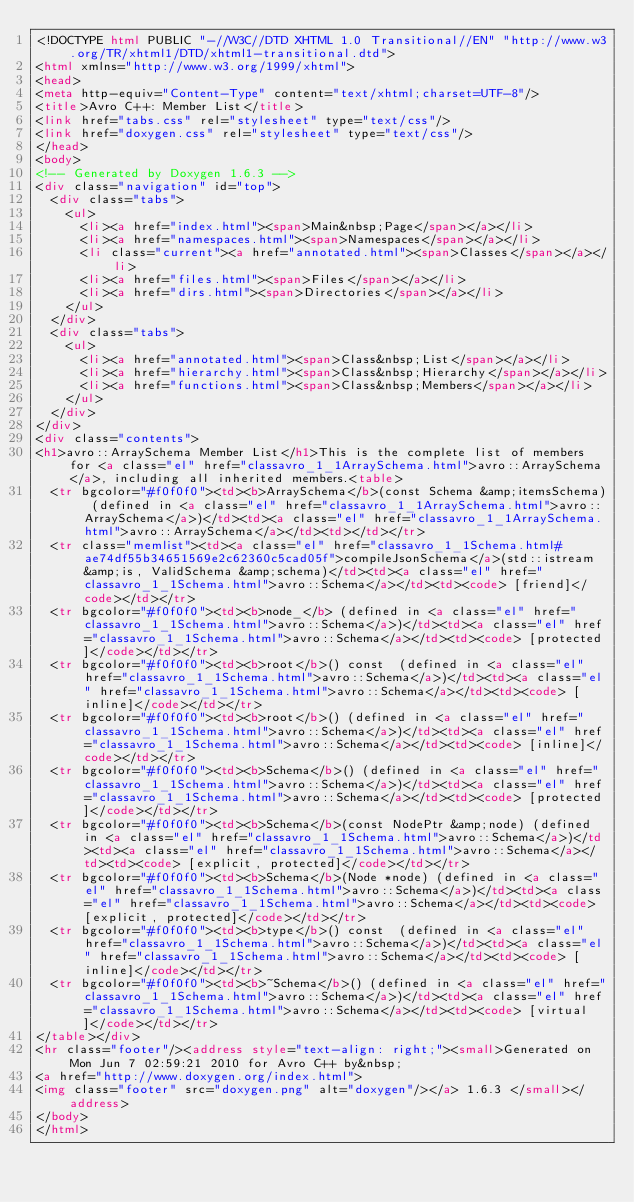Convert code to text. <code><loc_0><loc_0><loc_500><loc_500><_HTML_><!DOCTYPE html PUBLIC "-//W3C//DTD XHTML 1.0 Transitional//EN" "http://www.w3.org/TR/xhtml1/DTD/xhtml1-transitional.dtd">
<html xmlns="http://www.w3.org/1999/xhtml">
<head>
<meta http-equiv="Content-Type" content="text/xhtml;charset=UTF-8"/>
<title>Avro C++: Member List</title>
<link href="tabs.css" rel="stylesheet" type="text/css"/>
<link href="doxygen.css" rel="stylesheet" type="text/css"/>
</head>
<body>
<!-- Generated by Doxygen 1.6.3 -->
<div class="navigation" id="top">
  <div class="tabs">
    <ul>
      <li><a href="index.html"><span>Main&nbsp;Page</span></a></li>
      <li><a href="namespaces.html"><span>Namespaces</span></a></li>
      <li class="current"><a href="annotated.html"><span>Classes</span></a></li>
      <li><a href="files.html"><span>Files</span></a></li>
      <li><a href="dirs.html"><span>Directories</span></a></li>
    </ul>
  </div>
  <div class="tabs">
    <ul>
      <li><a href="annotated.html"><span>Class&nbsp;List</span></a></li>
      <li><a href="hierarchy.html"><span>Class&nbsp;Hierarchy</span></a></li>
      <li><a href="functions.html"><span>Class&nbsp;Members</span></a></li>
    </ul>
  </div>
</div>
<div class="contents">
<h1>avro::ArraySchema Member List</h1>This is the complete list of members for <a class="el" href="classavro_1_1ArraySchema.html">avro::ArraySchema</a>, including all inherited members.<table>
  <tr bgcolor="#f0f0f0"><td><b>ArraySchema</b>(const Schema &amp;itemsSchema) (defined in <a class="el" href="classavro_1_1ArraySchema.html">avro::ArraySchema</a>)</td><td><a class="el" href="classavro_1_1ArraySchema.html">avro::ArraySchema</a></td><td></td></tr>
  <tr class="memlist"><td><a class="el" href="classavro_1_1Schema.html#ae74df55b34651569e2c62360c5cad05f">compileJsonSchema</a>(std::istream &amp;is, ValidSchema &amp;schema)</td><td><a class="el" href="classavro_1_1Schema.html">avro::Schema</a></td><td><code> [friend]</code></td></tr>
  <tr bgcolor="#f0f0f0"><td><b>node_</b> (defined in <a class="el" href="classavro_1_1Schema.html">avro::Schema</a>)</td><td><a class="el" href="classavro_1_1Schema.html">avro::Schema</a></td><td><code> [protected]</code></td></tr>
  <tr bgcolor="#f0f0f0"><td><b>root</b>() const  (defined in <a class="el" href="classavro_1_1Schema.html">avro::Schema</a>)</td><td><a class="el" href="classavro_1_1Schema.html">avro::Schema</a></td><td><code> [inline]</code></td></tr>
  <tr bgcolor="#f0f0f0"><td><b>root</b>() (defined in <a class="el" href="classavro_1_1Schema.html">avro::Schema</a>)</td><td><a class="el" href="classavro_1_1Schema.html">avro::Schema</a></td><td><code> [inline]</code></td></tr>
  <tr bgcolor="#f0f0f0"><td><b>Schema</b>() (defined in <a class="el" href="classavro_1_1Schema.html">avro::Schema</a>)</td><td><a class="el" href="classavro_1_1Schema.html">avro::Schema</a></td><td><code> [protected]</code></td></tr>
  <tr bgcolor="#f0f0f0"><td><b>Schema</b>(const NodePtr &amp;node) (defined in <a class="el" href="classavro_1_1Schema.html">avro::Schema</a>)</td><td><a class="el" href="classavro_1_1Schema.html">avro::Schema</a></td><td><code> [explicit, protected]</code></td></tr>
  <tr bgcolor="#f0f0f0"><td><b>Schema</b>(Node *node) (defined in <a class="el" href="classavro_1_1Schema.html">avro::Schema</a>)</td><td><a class="el" href="classavro_1_1Schema.html">avro::Schema</a></td><td><code> [explicit, protected]</code></td></tr>
  <tr bgcolor="#f0f0f0"><td><b>type</b>() const  (defined in <a class="el" href="classavro_1_1Schema.html">avro::Schema</a>)</td><td><a class="el" href="classavro_1_1Schema.html">avro::Schema</a></td><td><code> [inline]</code></td></tr>
  <tr bgcolor="#f0f0f0"><td><b>~Schema</b>() (defined in <a class="el" href="classavro_1_1Schema.html">avro::Schema</a>)</td><td><a class="el" href="classavro_1_1Schema.html">avro::Schema</a></td><td><code> [virtual]</code></td></tr>
</table></div>
<hr class="footer"/><address style="text-align: right;"><small>Generated on Mon Jun 7 02:59:21 2010 for Avro C++ by&nbsp;
<a href="http://www.doxygen.org/index.html">
<img class="footer" src="doxygen.png" alt="doxygen"/></a> 1.6.3 </small></address>
</body>
</html>
</code> 